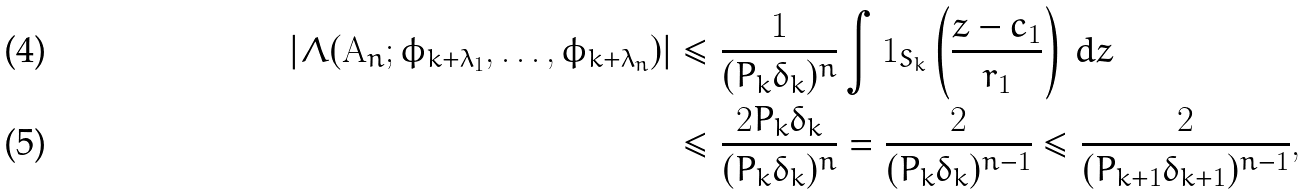Convert formula to latex. <formula><loc_0><loc_0><loc_500><loc_500>| \Lambda ( { \mathbf A } _ { n } ; \phi _ { k + \lambda _ { 1 } } , \dots , \phi _ { k + \lambda _ { n } } ) | & \leq \frac { 1 } { ( P _ { k } \delta _ { k } ) ^ { n } } \int \mathbf 1 _ { S _ { k } } \left ( \frac { z - c _ { 1 } } { r _ { 1 } } \right ) \, d z \\ & \leq \frac { 2 P _ { k } \delta _ { k } } { ( P _ { k } \delta _ { k } ) ^ { n } } = \frac { 2 } { ( P _ { k } \delta _ { k } ) ^ { n - 1 } } \leq \frac { 2 } { ( P _ { k + 1 } \delta _ { k + 1 } ) ^ { n - 1 } } ,</formula> 